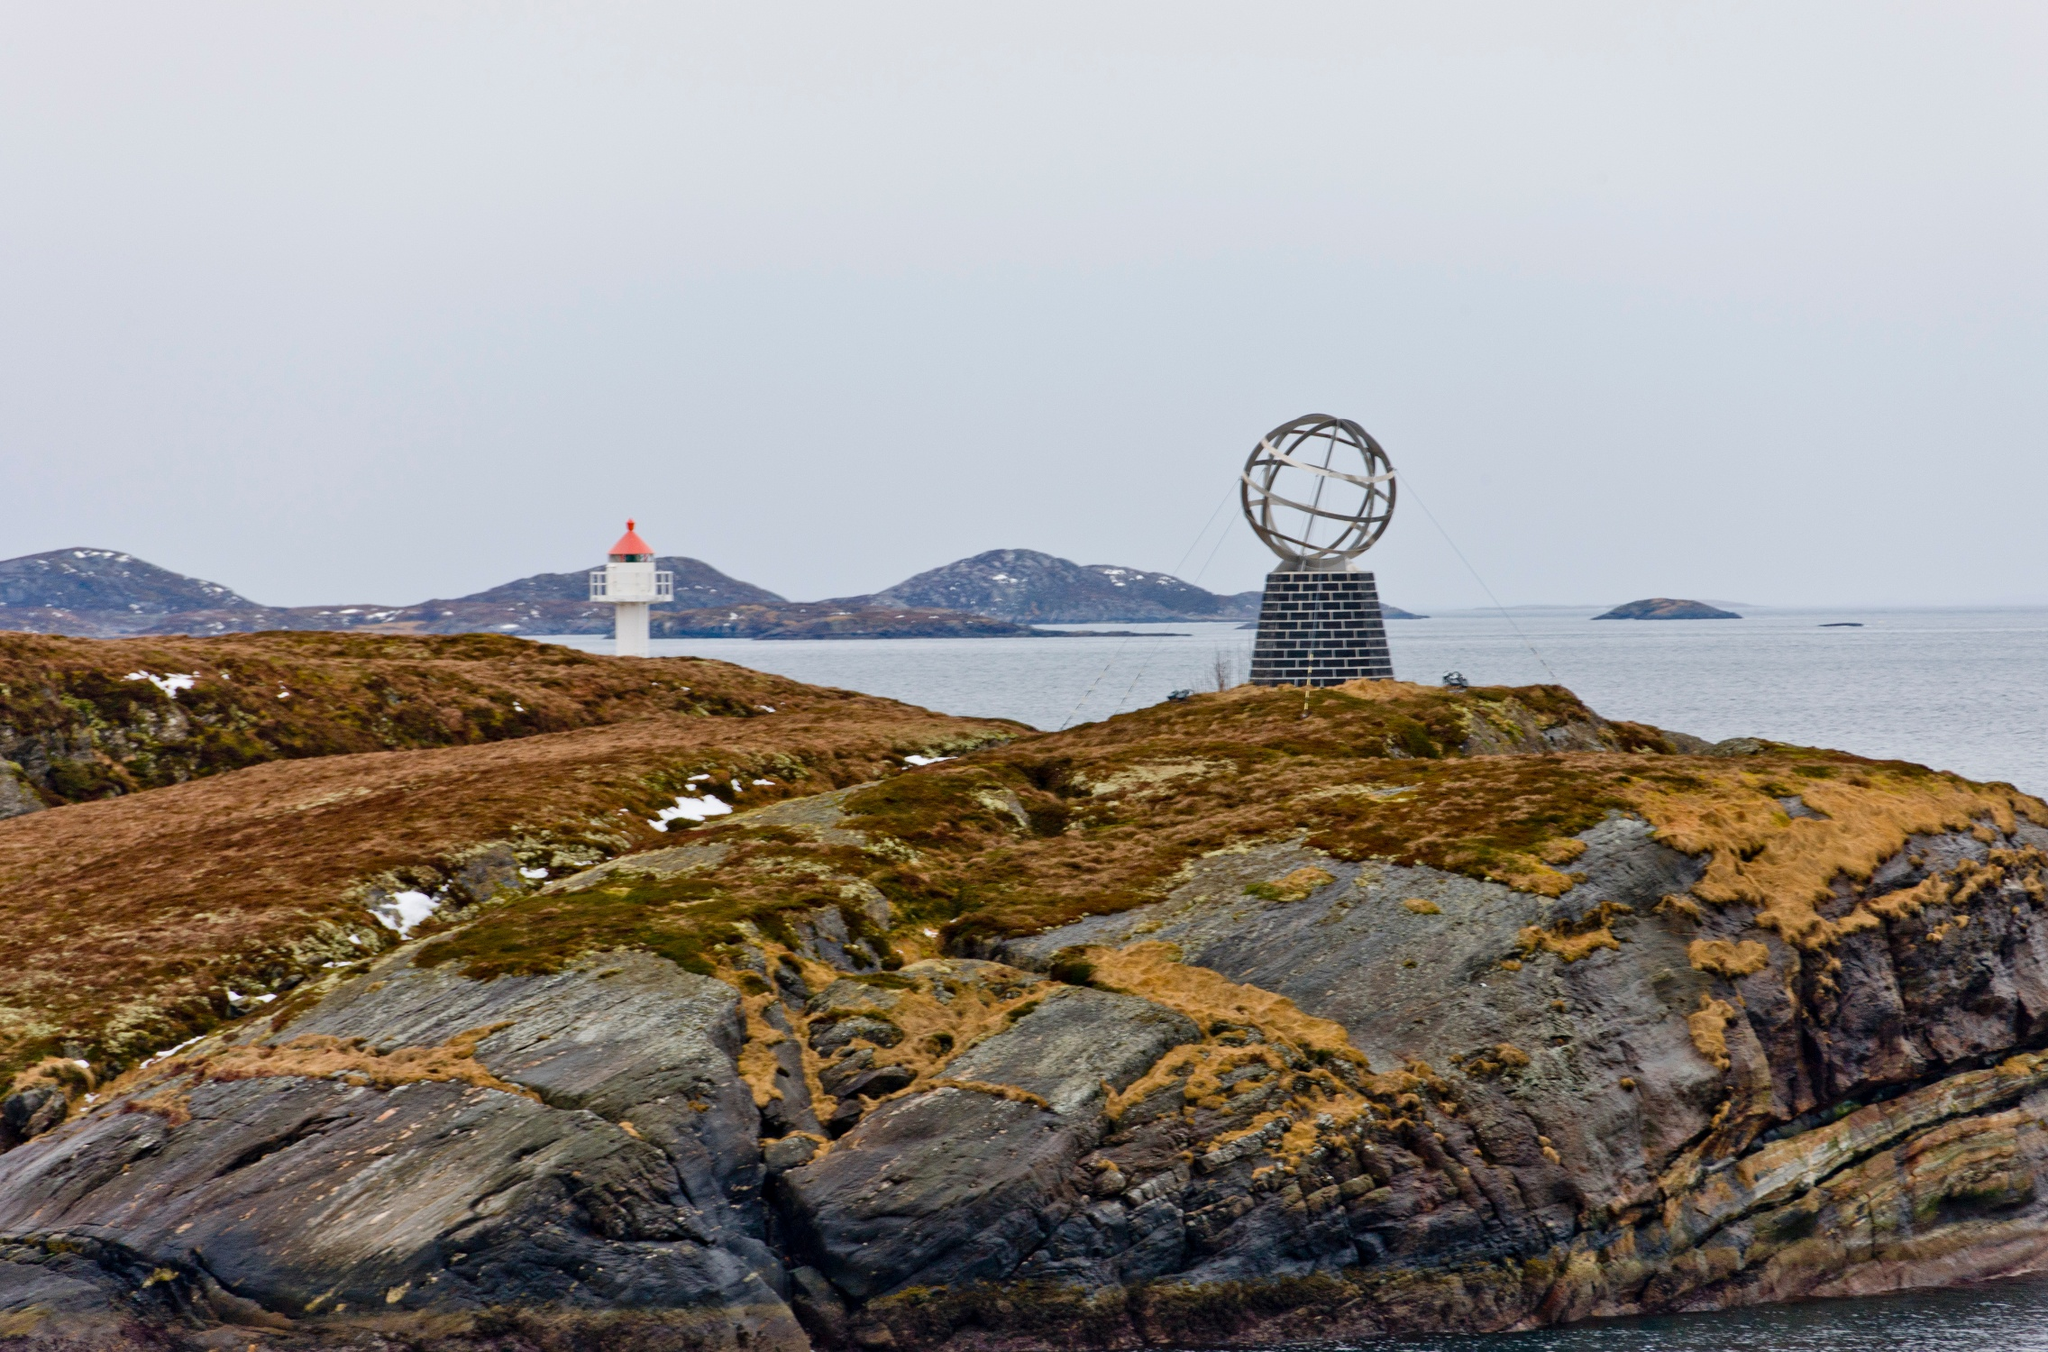Can you tell me more about the significance of the globe sculpture in this image? Absolutely, the globe sculpture at North Cape, also known as the 'Globus Monument', signifies the northernmost point in Europe that one can travel to by road. It was erected to mark this geographic and symbolic extremity, serving both as a monumental piece and a popular tourist attraction. The sculpture’s presence on a remote and rugged landscape highlights human achievement and exploration, celebrating the spirit of adventure in the face of the harsh Arctic environment. 